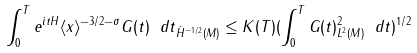Convert formula to latex. <formula><loc_0><loc_0><loc_500><loc_500>\| \int _ { 0 } ^ { T } e ^ { i t H } \langle x \rangle ^ { - 3 / 2 - \sigma } G ( t ) \ d t \| _ { \dot { H } ^ { - 1 / 2 } ( M ) } \leq K ( T ) ( \int _ { 0 } ^ { T } \| G ( t ) \| _ { L ^ { 2 } ( M ) } ^ { 2 } \ d t ) ^ { 1 / 2 }</formula> 